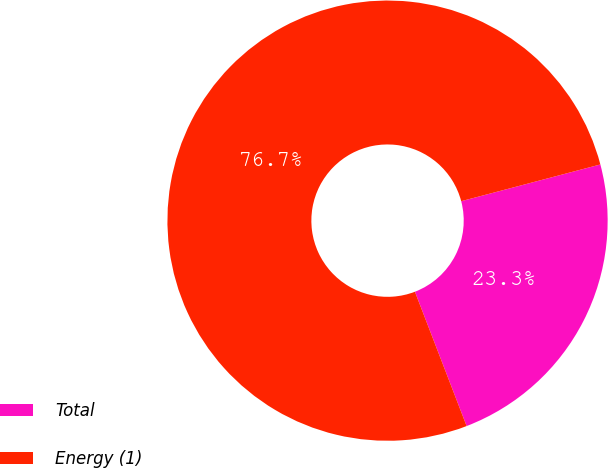<chart> <loc_0><loc_0><loc_500><loc_500><pie_chart><fcel>Total<fcel>Energy (1)<nl><fcel>23.26%<fcel>76.74%<nl></chart> 